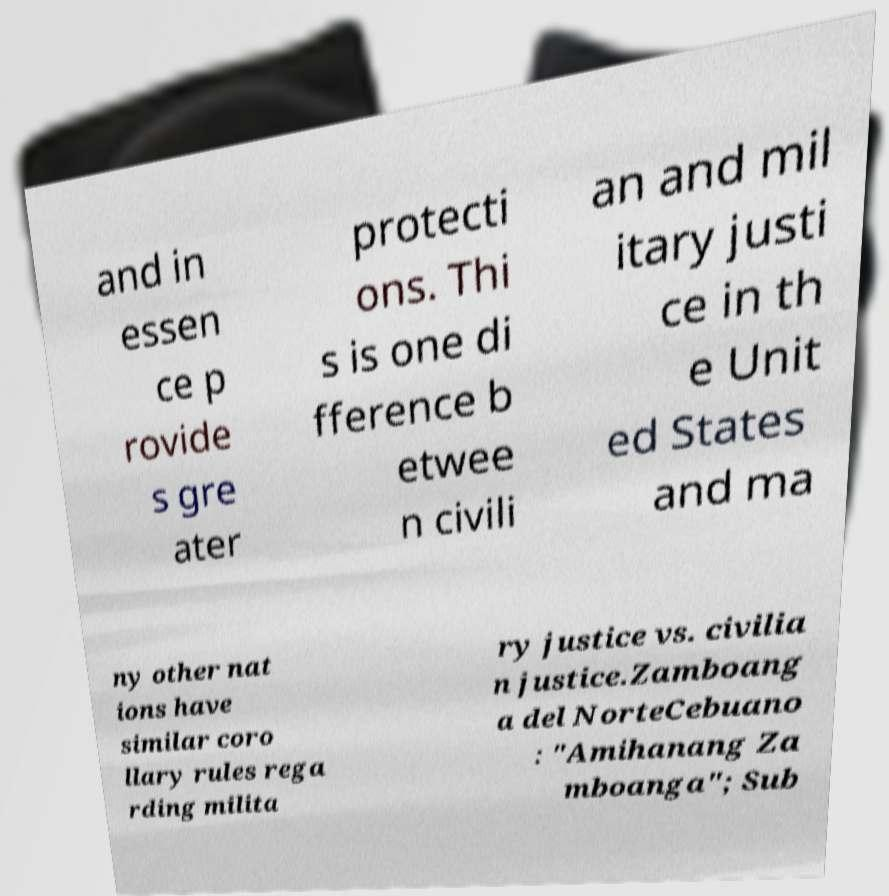Please read and relay the text visible in this image. What does it say? and in essen ce p rovide s gre ater protecti ons. Thi s is one di fference b etwee n civili an and mil itary justi ce in th e Unit ed States and ma ny other nat ions have similar coro llary rules rega rding milita ry justice vs. civilia n justice.Zamboang a del NorteCebuano : "Amihanang Za mboanga"; Sub 